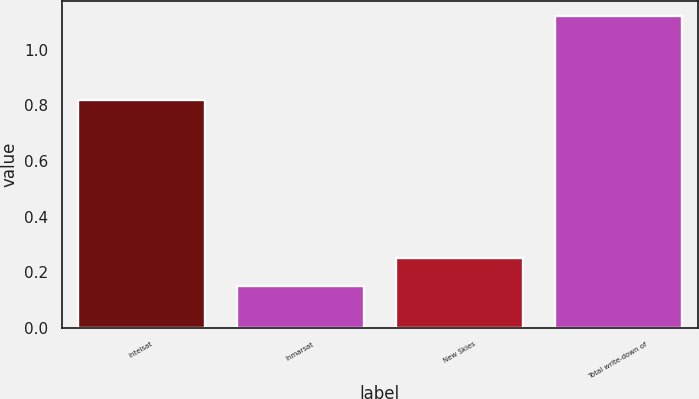Convert chart to OTSL. <chart><loc_0><loc_0><loc_500><loc_500><bar_chart><fcel>Intelsat<fcel>Inmarsat<fcel>New Skies<fcel>Total write-down of<nl><fcel>0.82<fcel>0.15<fcel>0.25<fcel>1.12<nl></chart> 